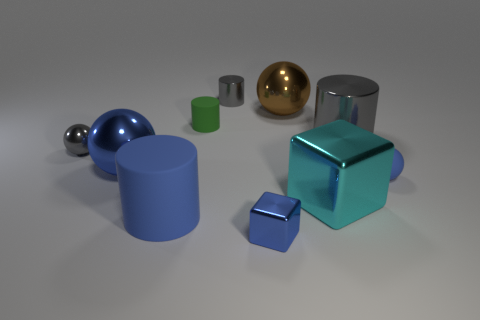What number of other objects are the same material as the large block?
Your answer should be compact. 6. Is the number of green cylinders less than the number of large cylinders?
Give a very brief answer. Yes. Are the gray ball and the gray cylinder in front of the green matte object made of the same material?
Provide a succinct answer. Yes. The big metal object to the left of the tiny blue shiny object has what shape?
Provide a succinct answer. Sphere. Is there any other thing that is the same color as the big rubber thing?
Your response must be concise. Yes. Are there fewer tiny cylinders in front of the big blue cylinder than large metal blocks?
Offer a very short reply. Yes. What number of cylinders are the same size as the blue shiny cube?
Offer a very short reply. 2. What shape is the tiny thing that is the same color as the matte ball?
Provide a succinct answer. Cube. What is the shape of the gray metal object that is on the left side of the small gray thing to the right of the small ball that is to the left of the tiny metal cylinder?
Offer a terse response. Sphere. The big metal thing that is in front of the blue matte ball is what color?
Offer a very short reply. Cyan. 